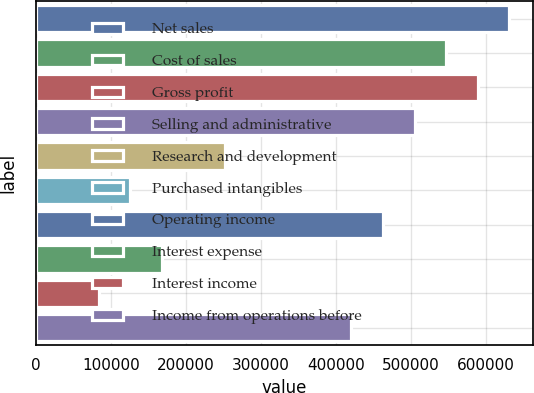<chart> <loc_0><loc_0><loc_500><loc_500><bar_chart><fcel>Net sales<fcel>Cost of sales<fcel>Gross profit<fcel>Selling and administrative<fcel>Research and development<fcel>Purchased intangibles<fcel>Operating income<fcel>Interest expense<fcel>Interest income<fcel>Income from operations before<nl><fcel>630686<fcel>546595<fcel>588641<fcel>504549<fcel>252275<fcel>126138<fcel>462504<fcel>168184<fcel>84092.4<fcel>420458<nl></chart> 